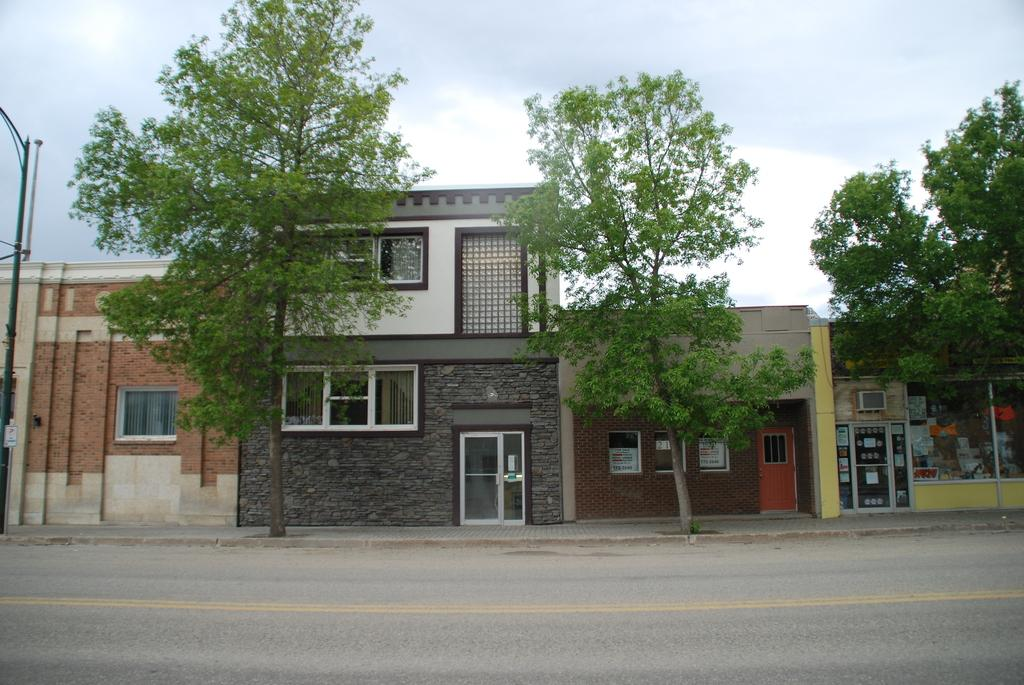What is located in the center of the image? There are buildings in the center of the image. What is at the bottom of the image? There is a road at the bottom of the image. What can be seen on the left side of the image? There are poles on the left side of the image. What type of vegetation is visible in the image? Trees are visible in the image. What is visible in the background of the image? The sky is visible in the background of the image. What type of plants are being used by the army in the image? There is no army or plants related to the army present in the image. What is the condition of the plants in the image? There is no specific condition mentioned for the plants in the image, but they appear to be healthy and green. 